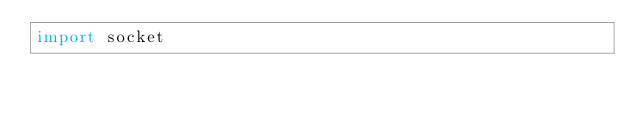Convert code to text. <code><loc_0><loc_0><loc_500><loc_500><_Python_>import socket
</code> 